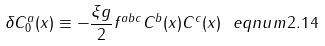<formula> <loc_0><loc_0><loc_500><loc_500>\delta C _ { 0 } ^ { a } ( x ) \equiv - \frac { \xi g } 2 f ^ { a b c } C ^ { b } ( x ) C ^ { c } ( x ) \ e q n u m { 2 . 1 4 }</formula> 